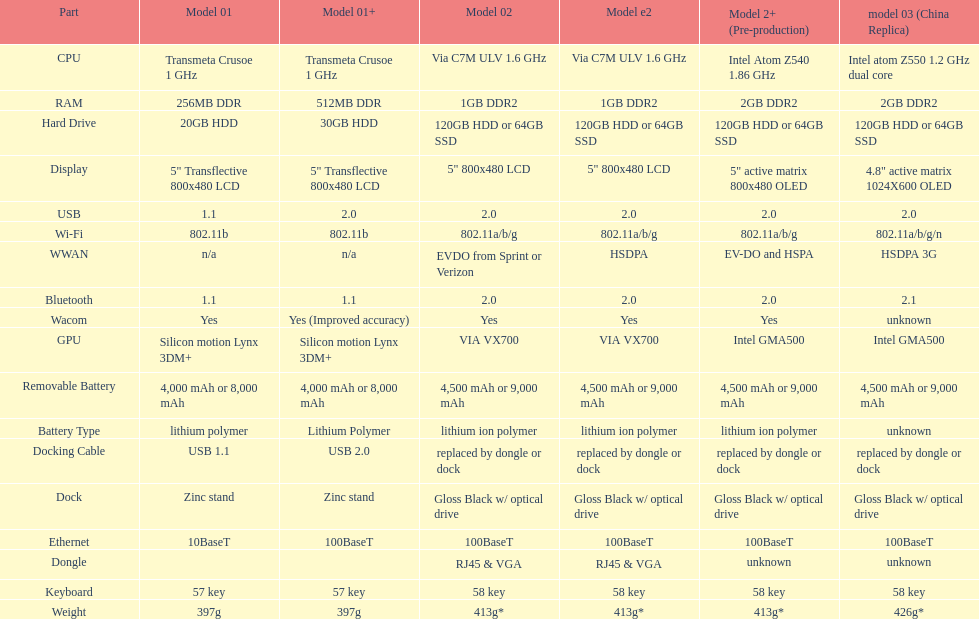What is the next highest hard drive available after the 30gb model? 64GB SSD. 